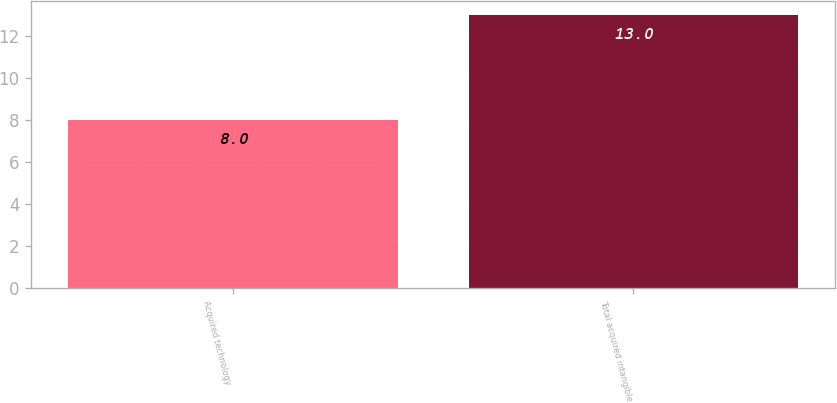Convert chart to OTSL. <chart><loc_0><loc_0><loc_500><loc_500><bar_chart><fcel>Acquired technology<fcel>Total acquired intangible<nl><fcel>8<fcel>13<nl></chart> 